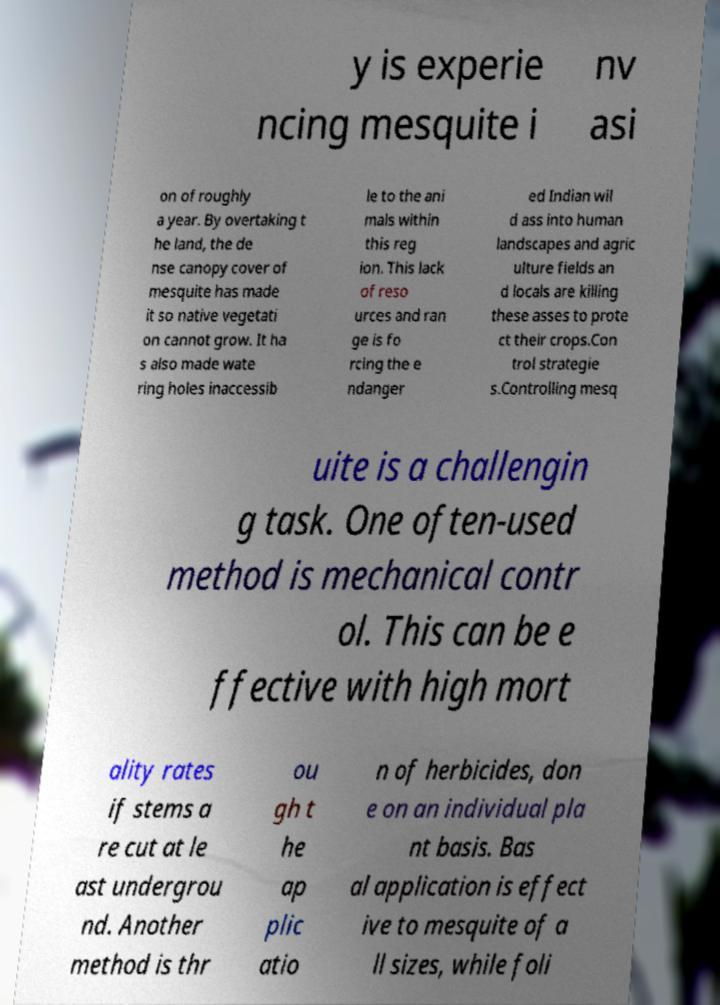For documentation purposes, I need the text within this image transcribed. Could you provide that? y is experie ncing mesquite i nv asi on of roughly a year. By overtaking t he land, the de nse canopy cover of mesquite has made it so native vegetati on cannot grow. It ha s also made wate ring holes inaccessib le to the ani mals within this reg ion. This lack of reso urces and ran ge is fo rcing the e ndanger ed Indian wil d ass into human landscapes and agric ulture fields an d locals are killing these asses to prote ct their crops.Con trol strategie s.Controlling mesq uite is a challengin g task. One often-used method is mechanical contr ol. This can be e ffective with high mort ality rates if stems a re cut at le ast undergrou nd. Another method is thr ou gh t he ap plic atio n of herbicides, don e on an individual pla nt basis. Bas al application is effect ive to mesquite of a ll sizes, while foli 